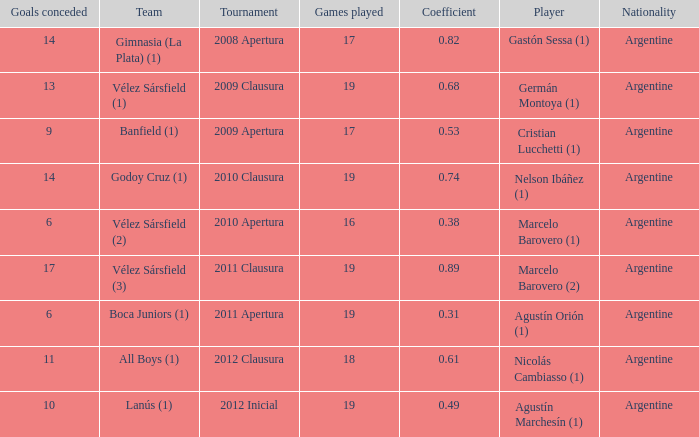How many nationalities are there for the 2011 apertura? 1.0. 